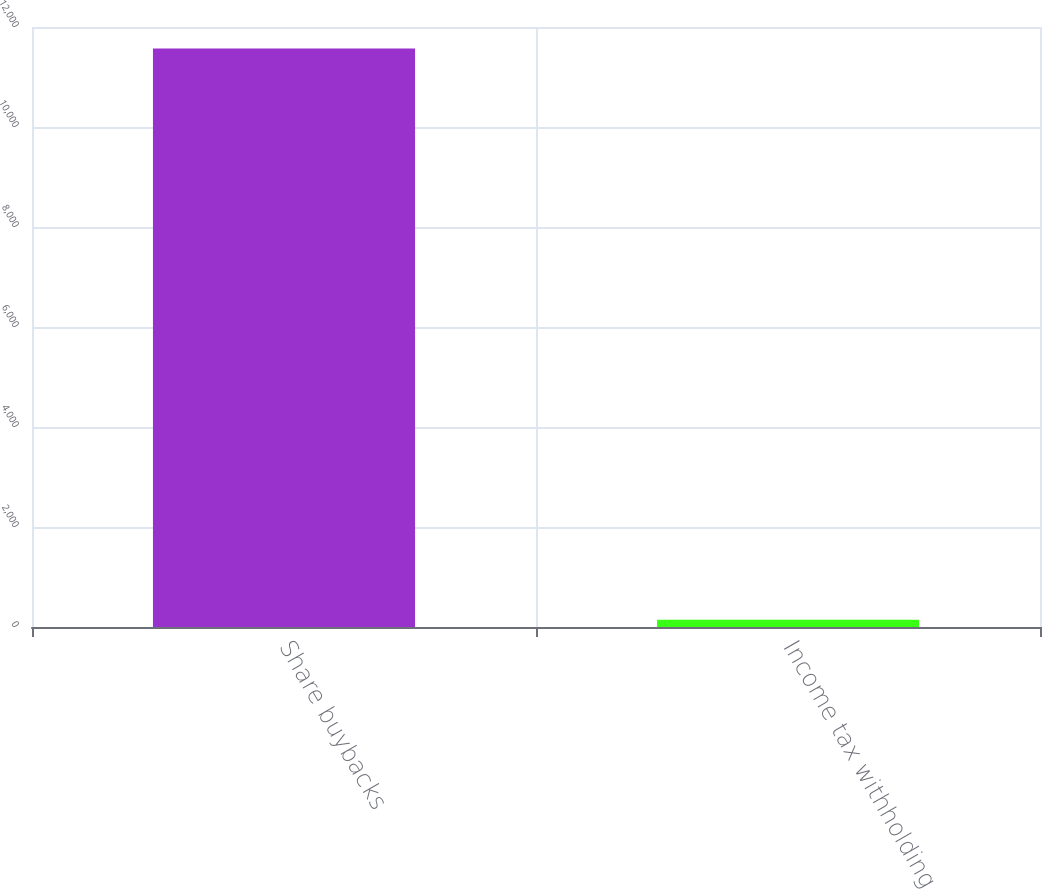<chart> <loc_0><loc_0><loc_500><loc_500><bar_chart><fcel>Share buybacks<fcel>Income tax withholding<nl><fcel>11570<fcel>145<nl></chart> 